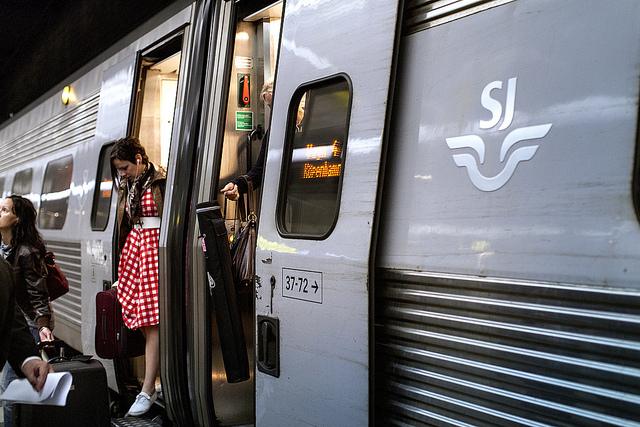Where was this photo taken?
Be succinct. Train station. Is the door locked?
Write a very short answer. No. Is the woman alighting?
Concise answer only. Yes. What is the train resting on?
Be succinct. Tracks. Is the train moving?
Be succinct. No. What color is the suitcase?
Give a very brief answer. Black. 